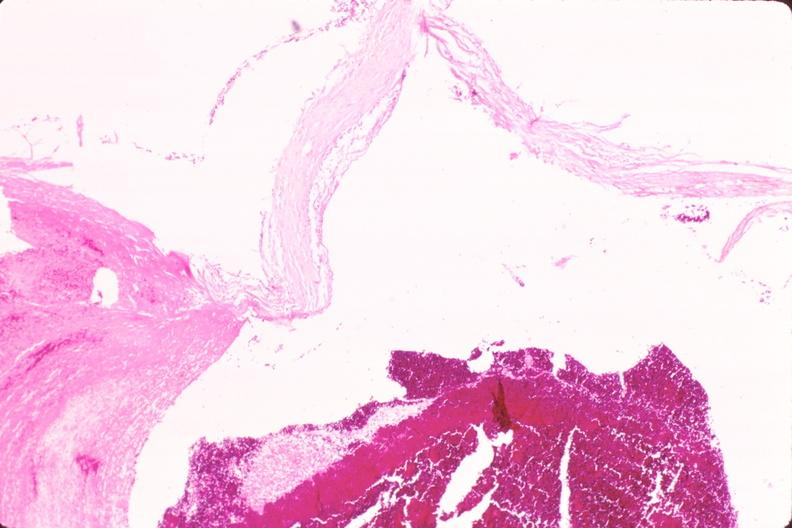s vasculature present?
Answer the question using a single word or phrase. Yes 